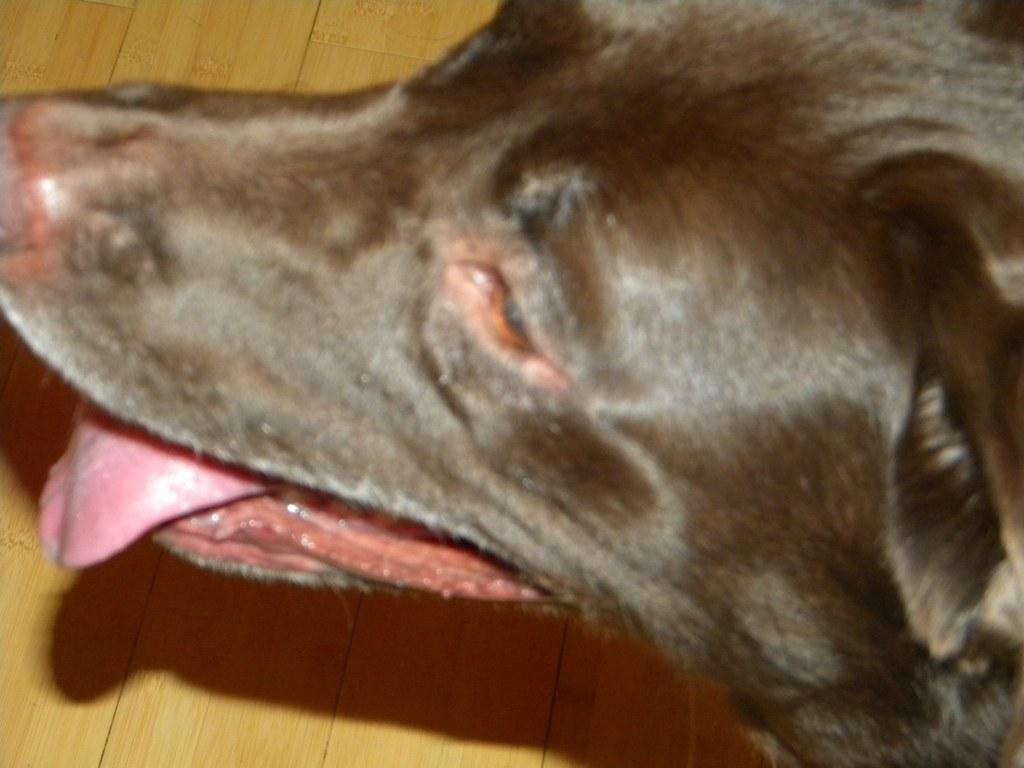What type of animal is present in the image? There is a dog in the image. What can be seen in the background of the image? There is a wall visible in the background of the image. Where is the nest located in the image? There is no nest present in the image; it only features a dog and a wall in the background. 